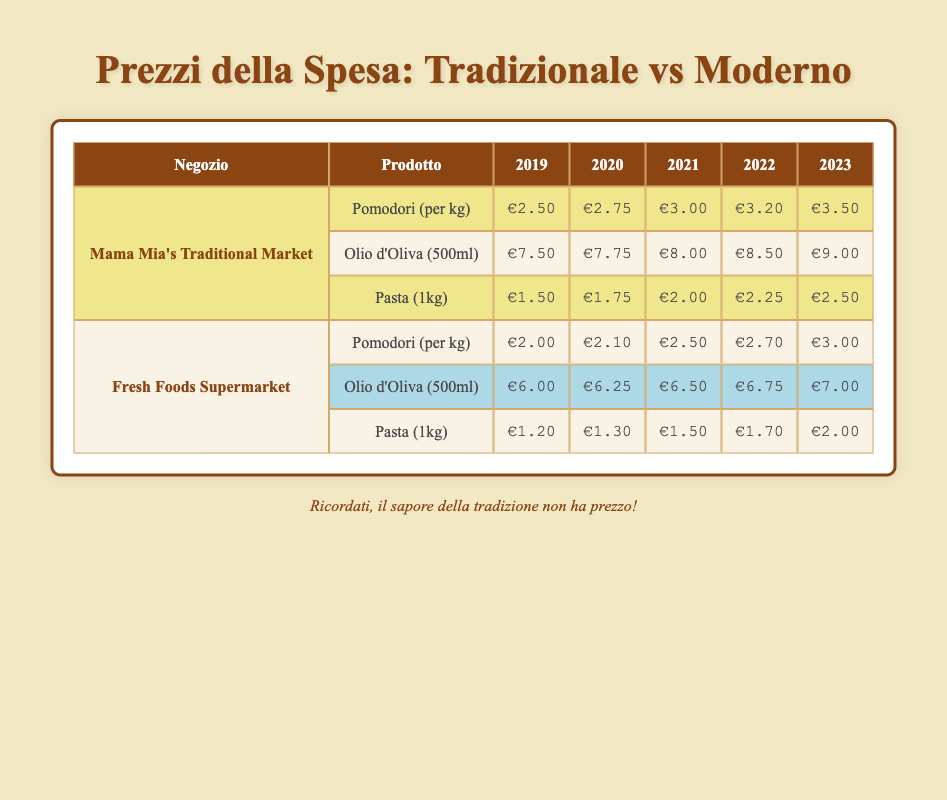What was the price of tomatoes in Mama Mia's Traditional Market in 2021? In the table, under the row for Mama Mia's Traditional Market and the column for the year 2021, the price of tomatoes (per kg) is listed as €3.00.
Answer: €3.00 How much did the price of olive oil change from 2019 to 2023 in the Fresh Foods Supermarket? In the Fresh Foods Supermarket, the price of olive oil in 2019 was €6.00, and in 2023 it is €7.00. The change is €7.00 - €6.00 = €1.00.
Answer: €1.00 Which store had the cheaper pasta in 2020? In 2020, Mama Mia's Traditional Market sold pasta for €1.75, while Fresh Foods Supermarket had it for €1.30. Comparing the two, Fresh Foods Supermarket had the lower price.
Answer: Fresh Foods Supermarket What is the average price of tomatoes over the five years in Mama Mia's Traditional Market? The prices of tomatoes in Mama Mia's Traditional Market from 2019 to 2023 are €2.50, €2.75, €3.00, €3.20, and €3.50. The sum is €2.50 + €2.75 + €3.00 + €3.20 + €3.50 = €14.95, and then dividing by 5 gives an average of €14.95 / 5 = €2.99.
Answer: €2.99 Is the average price of olive oil higher in 2023 than in 2019 at Mama Mia's Traditional Market? At Mama Mia's Traditional Market, the price of olive oil in 2019 was €7.50 and in 2023 it was €9.00. The average of the two values is (€7.50 + €9.00) / 2 = €8.25, which shows that in 2023 the price is higher than the average of those two years.
Answer: Yes What was the total price increase of pasta from 2019 to 2023 in Mama Mia's Traditional Market? The price of pasta in Mama Mia's Traditional Market in 2019 was €1.50 and in 2023 it was €2.50. The price increase is €2.50 - €1.50 = €1.00.
Answer: €1.00 Which item in the Fresh Foods Supermarket saw the least price increase from 2019 to 2023? The prices for the three items in 2019 and 2023 are as follows: Tomatoes increased from €2.00 to €3.00 (+€1.00), Olive Oil from €6.00 to €7.00 (+€1.00), and Pasta from €1.20 to €2.00 (+€0.80). Hence, pasta had the least increase of €0.80.
Answer: Pasta How much more expensive was olive oil in 2023 compared to tomatoes in 2023 at the Fresh Foods Supermarket? In 2023, olive oil was priced at €7.00, and tomatoes at €3.00 in the Fresh Foods Supermarket. The difference is €7.00 - €3.00 = €4.00.
Answer: €4.00 What is the difference between the highest and lowest price of pasta across both stores in 2023? In 2023, Mama Mia's Traditional Market sold pasta for €2.50, while Fresh Foods Supermarket sold it for €2.00. Thus, the difference is €2.50 - €2.00 = €0.50.
Answer: €0.50 